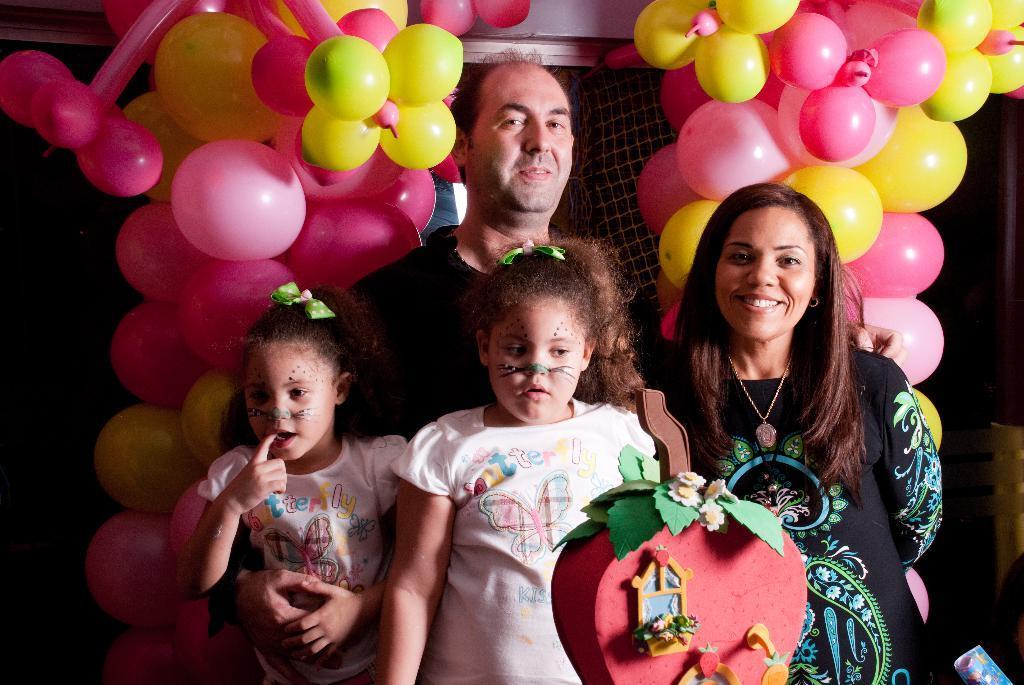Please provide a concise description of this image. In the image we can see the man, woman and two children, they are wearing clothes and the man and the women are smiling. Here we can see the balloons of different colors and an object in heart shape, and the background is dark. 